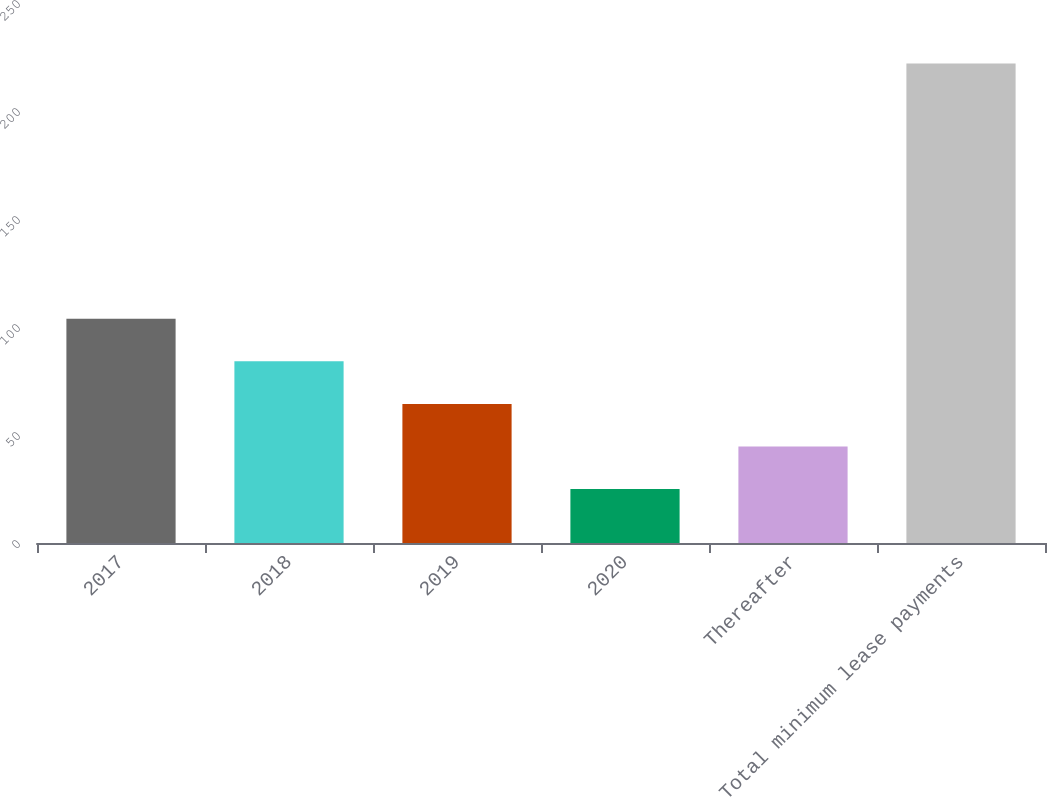<chart> <loc_0><loc_0><loc_500><loc_500><bar_chart><fcel>2017<fcel>2018<fcel>2019<fcel>2020<fcel>Thereafter<fcel>Total minimum lease payments<nl><fcel>103.8<fcel>84.1<fcel>64.4<fcel>25<fcel>44.7<fcel>222<nl></chart> 